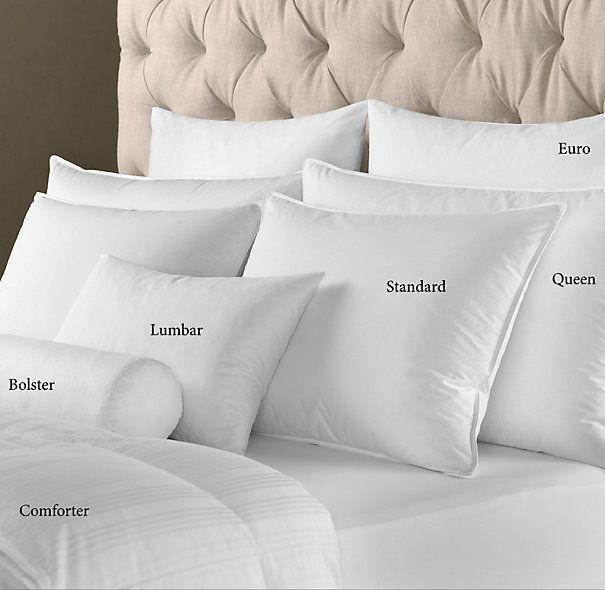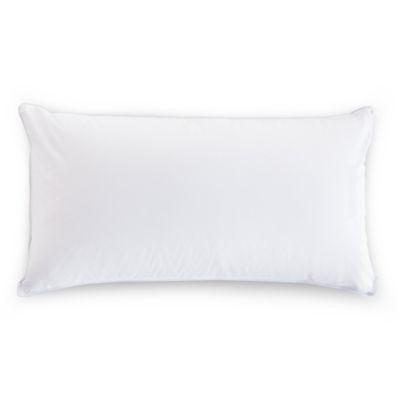The first image is the image on the left, the second image is the image on the right. Considering the images on both sides, is "The pillows in the image on the left are propped against a padded headboard." valid? Answer yes or no. Yes. The first image is the image on the left, the second image is the image on the right. Analyze the images presented: Is the assertion "An image shows a bed with tufted headboard and at least six pillows." valid? Answer yes or no. Yes. 